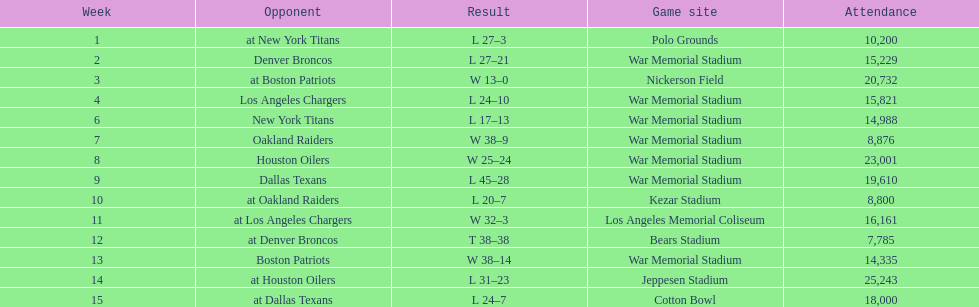The total number of games played at war memorial stadium was how many? 7. 